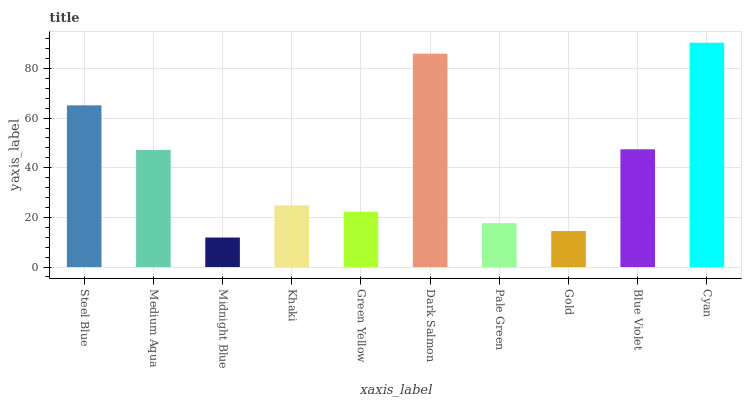Is Midnight Blue the minimum?
Answer yes or no. Yes. Is Cyan the maximum?
Answer yes or no. Yes. Is Medium Aqua the minimum?
Answer yes or no. No. Is Medium Aqua the maximum?
Answer yes or no. No. Is Steel Blue greater than Medium Aqua?
Answer yes or no. Yes. Is Medium Aqua less than Steel Blue?
Answer yes or no. Yes. Is Medium Aqua greater than Steel Blue?
Answer yes or no. No. Is Steel Blue less than Medium Aqua?
Answer yes or no. No. Is Medium Aqua the high median?
Answer yes or no. Yes. Is Khaki the low median?
Answer yes or no. Yes. Is Gold the high median?
Answer yes or no. No. Is Steel Blue the low median?
Answer yes or no. No. 